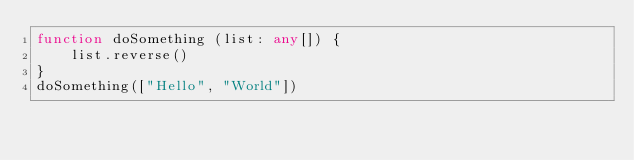<code> <loc_0><loc_0><loc_500><loc_500><_TypeScript_>function doSomething (list: any[]) {
    list.reverse()
}
doSomething(["Hello", "World"])</code> 